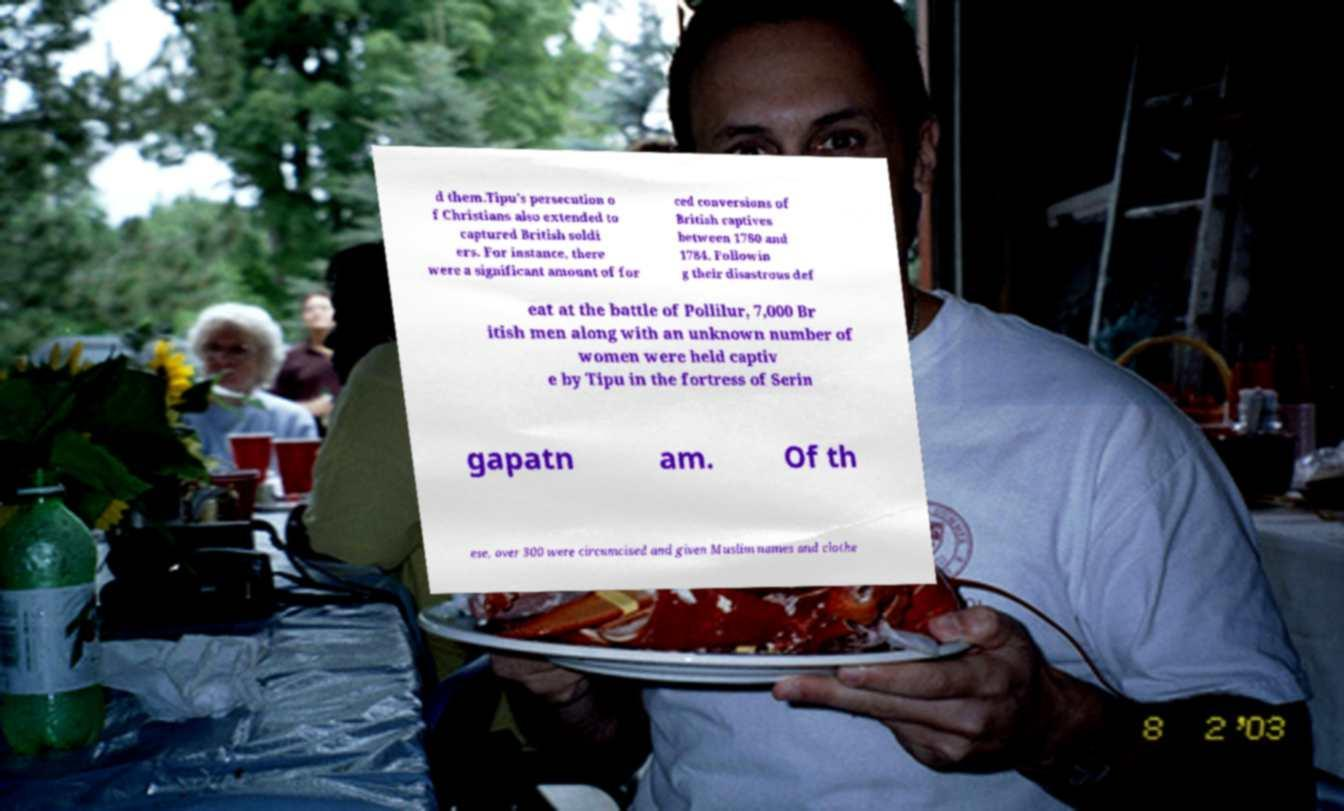What messages or text are displayed in this image? I need them in a readable, typed format. d them.Tipu's persecution o f Christians also extended to captured British soldi ers. For instance, there were a significant amount of for ced conversions of British captives between 1780 and 1784. Followin g their disastrous def eat at the battle of Pollilur, 7,000 Br itish men along with an unknown number of women were held captiv e by Tipu in the fortress of Serin gapatn am. Of th ese, over 300 were circumcised and given Muslim names and clothe 